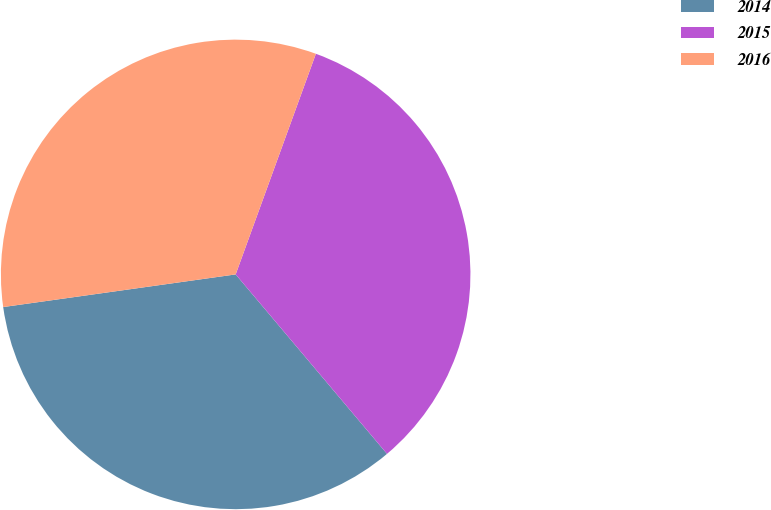Convert chart to OTSL. <chart><loc_0><loc_0><loc_500><loc_500><pie_chart><fcel>2014<fcel>2015<fcel>2016<nl><fcel>33.93%<fcel>33.3%<fcel>32.77%<nl></chart> 